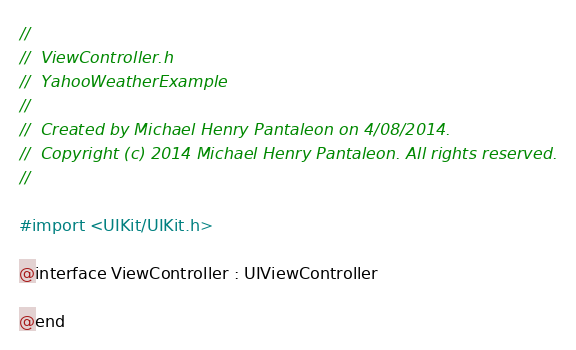<code> <loc_0><loc_0><loc_500><loc_500><_C_>//
//  ViewController.h
//  YahooWeatherExample
//
//  Created by Michael Henry Pantaleon on 4/08/2014.
//  Copyright (c) 2014 Michael Henry Pantaleon. All rights reserved.
//

#import <UIKit/UIKit.h>

@interface ViewController : UIViewController

@end
</code> 